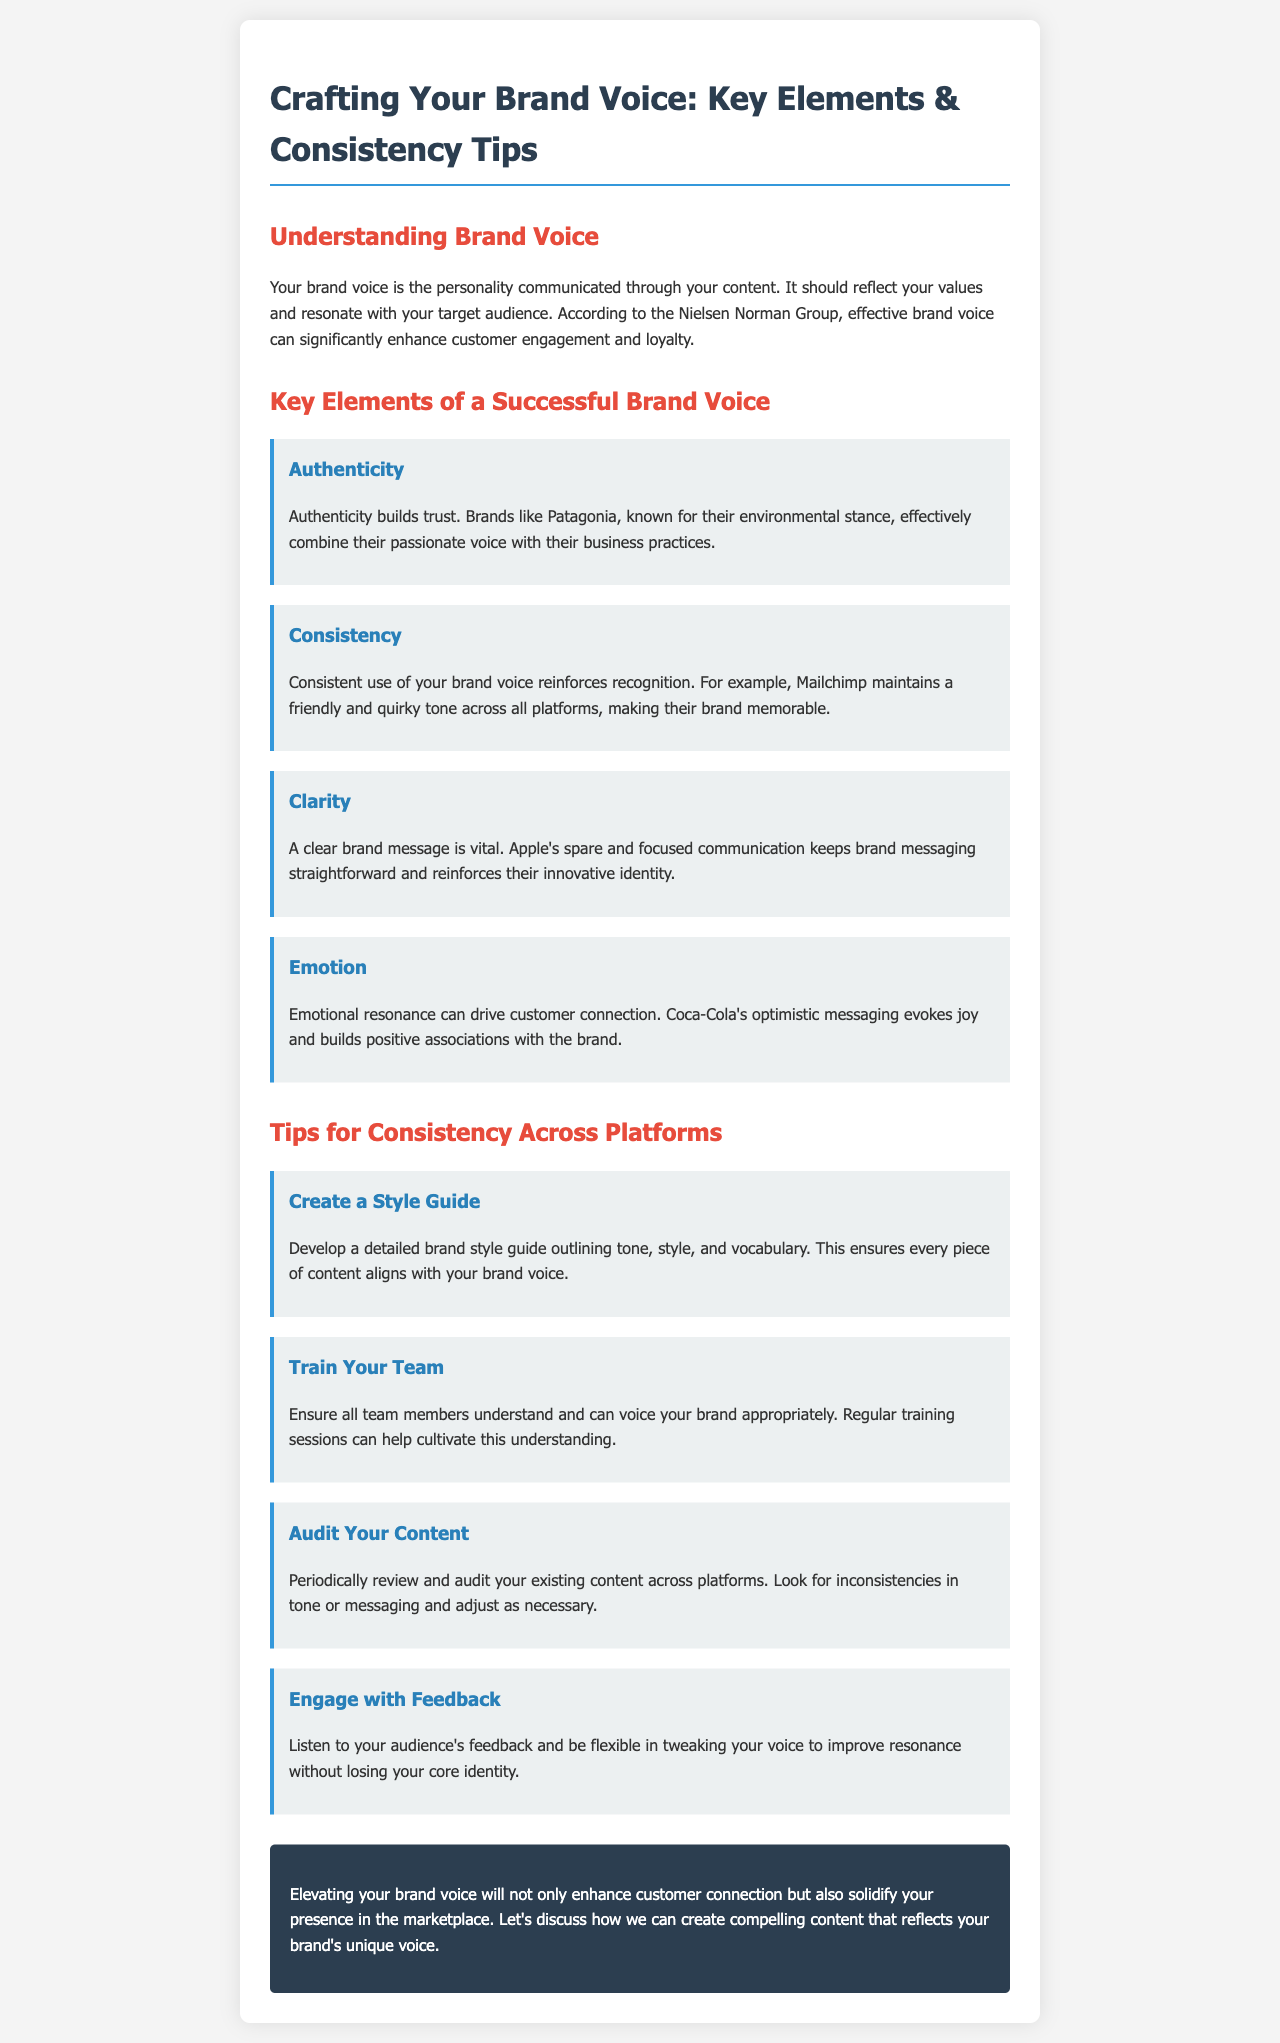What is the title of the document? The document is titled "Crafting Your Brand Voice: Key Elements & Consistency Tips."
Answer: Crafting Your Brand Voice: Key Elements & Consistency Tips What is one key element of a successful brand voice? The document lists authenticity, consistency, clarity, and emotion as key elements of a successful brand voice.
Answer: Authenticity Which brand is mentioned as an example of emotional resonance? Coca-Cola is mentioned as an example of emotional resonance driving customer connection.
Answer: Coca-Cola What advice is given for maintaining content consistency? The document suggests creating a style guide to ensure every piece of content aligns with brand voice.
Answer: Create a style guide How many tips for consistency across platforms are provided? There are four tips listed for maintaining consistency across platforms in the document.
Answer: Four Who is mentioned as a brand that maintains a friendly tone? Mailchimp is highlighted as a brand that maintains a friendly and quirky tone across platforms.
Answer: Mailchimp What should you do with audience feedback? The document advises engaging with feedback to tweak your voice while preserving core identity.
Answer: Engage with feedback What color is used for headings in the document? The headings in the document are colored #2c3e50.
Answer: #2c3e50 